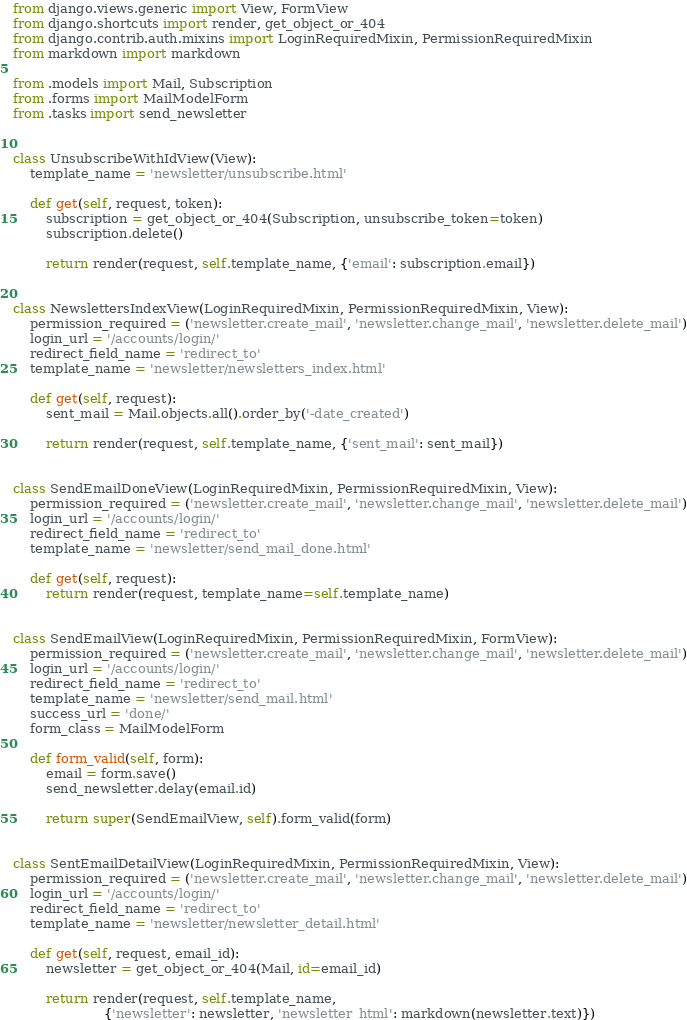Convert code to text. <code><loc_0><loc_0><loc_500><loc_500><_Python_>from django.views.generic import View, FormView
from django.shortcuts import render, get_object_or_404
from django.contrib.auth.mixins import LoginRequiredMixin, PermissionRequiredMixin
from markdown import markdown

from .models import Mail, Subscription
from .forms import MailModelForm
from .tasks import send_newsletter


class UnsubscribeWithIdView(View):
    template_name = 'newsletter/unsubscribe.html'

    def get(self, request, token):
        subscription = get_object_or_404(Subscription, unsubscribe_token=token)
        subscription.delete()

        return render(request, self.template_name, {'email': subscription.email})


class NewslettersIndexView(LoginRequiredMixin, PermissionRequiredMixin, View):
    permission_required = ('newsletter.create_mail', 'newsletter.change_mail', 'newsletter.delete_mail')
    login_url = '/accounts/login/'
    redirect_field_name = 'redirect_to'
    template_name = 'newsletter/newsletters_index.html'

    def get(self, request):
        sent_mail = Mail.objects.all().order_by('-date_created')

        return render(request, self.template_name, {'sent_mail': sent_mail})


class SendEmailDoneView(LoginRequiredMixin, PermissionRequiredMixin, View):
    permission_required = ('newsletter.create_mail', 'newsletter.change_mail', 'newsletter.delete_mail')
    login_url = '/accounts/login/'
    redirect_field_name = 'redirect_to'
    template_name = 'newsletter/send_mail_done.html'

    def get(self, request):
        return render(request, template_name=self.template_name)


class SendEmailView(LoginRequiredMixin, PermissionRequiredMixin, FormView):
    permission_required = ('newsletter.create_mail', 'newsletter.change_mail', 'newsletter.delete_mail')
    login_url = '/accounts/login/'
    redirect_field_name = 'redirect_to'
    template_name = 'newsletter/send_mail.html'
    success_url = 'done/'
    form_class = MailModelForm

    def form_valid(self, form):
        email = form.save()
        send_newsletter.delay(email.id)

        return super(SendEmailView, self).form_valid(form)


class SentEmailDetailView(LoginRequiredMixin, PermissionRequiredMixin, View):
    permission_required = ('newsletter.create_mail', 'newsletter.change_mail', 'newsletter.delete_mail')
    login_url = '/accounts/login/'
    redirect_field_name = 'redirect_to'
    template_name = 'newsletter/newsletter_detail.html'

    def get(self, request, email_id):
        newsletter = get_object_or_404(Mail, id=email_id)

        return render(request, self.template_name,
                      {'newsletter': newsletter, 'newsletter_html': markdown(newsletter.text)})
</code> 